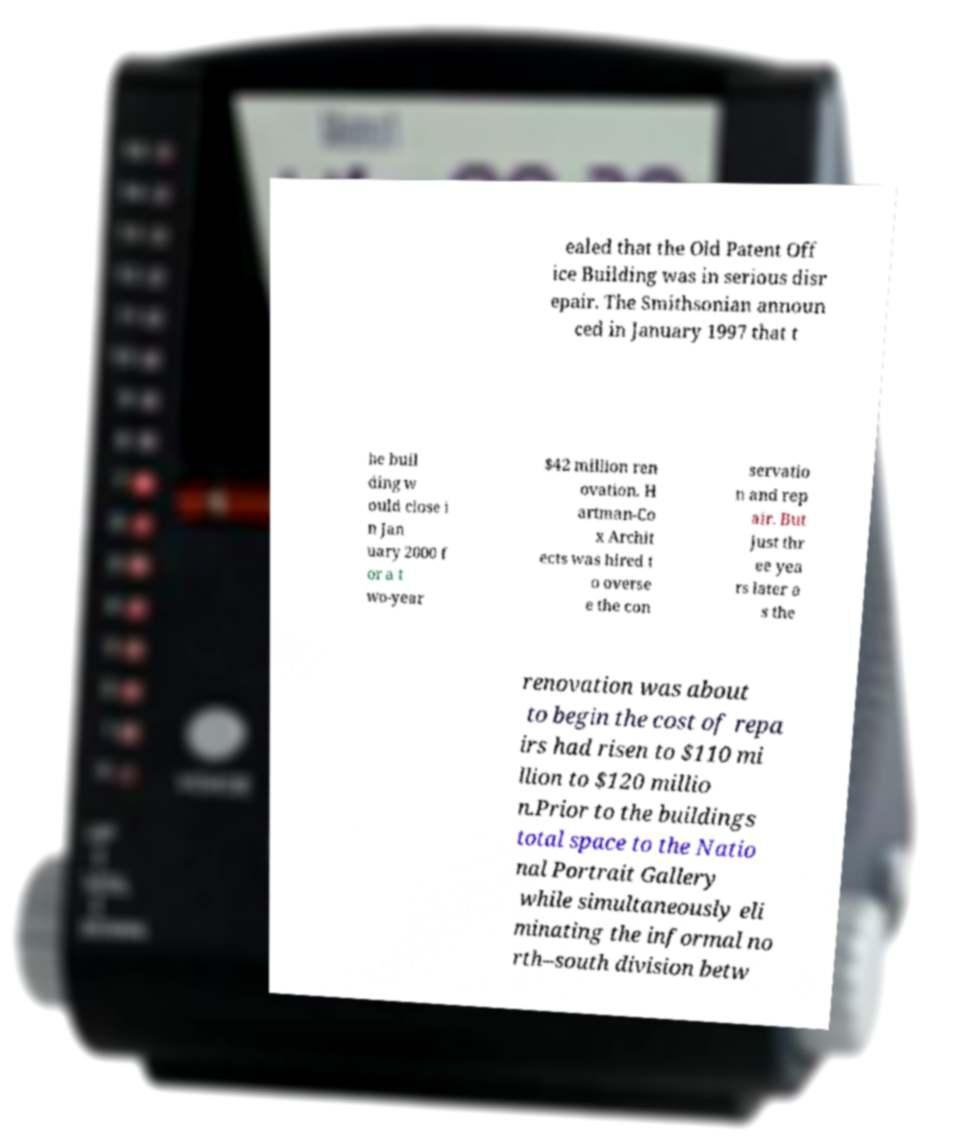Can you read and provide the text displayed in the image?This photo seems to have some interesting text. Can you extract and type it out for me? ealed that the Old Patent Off ice Building was in serious disr epair. The Smithsonian announ ced in January 1997 that t he buil ding w ould close i n Jan uary 2000 f or a t wo-year $42 million ren ovation. H artman-Co x Archit ects was hired t o overse e the con servatio n and rep air. But just thr ee yea rs later a s the renovation was about to begin the cost of repa irs had risen to $110 mi llion to $120 millio n.Prior to the buildings total space to the Natio nal Portrait Gallery while simultaneously eli minating the informal no rth–south division betw 